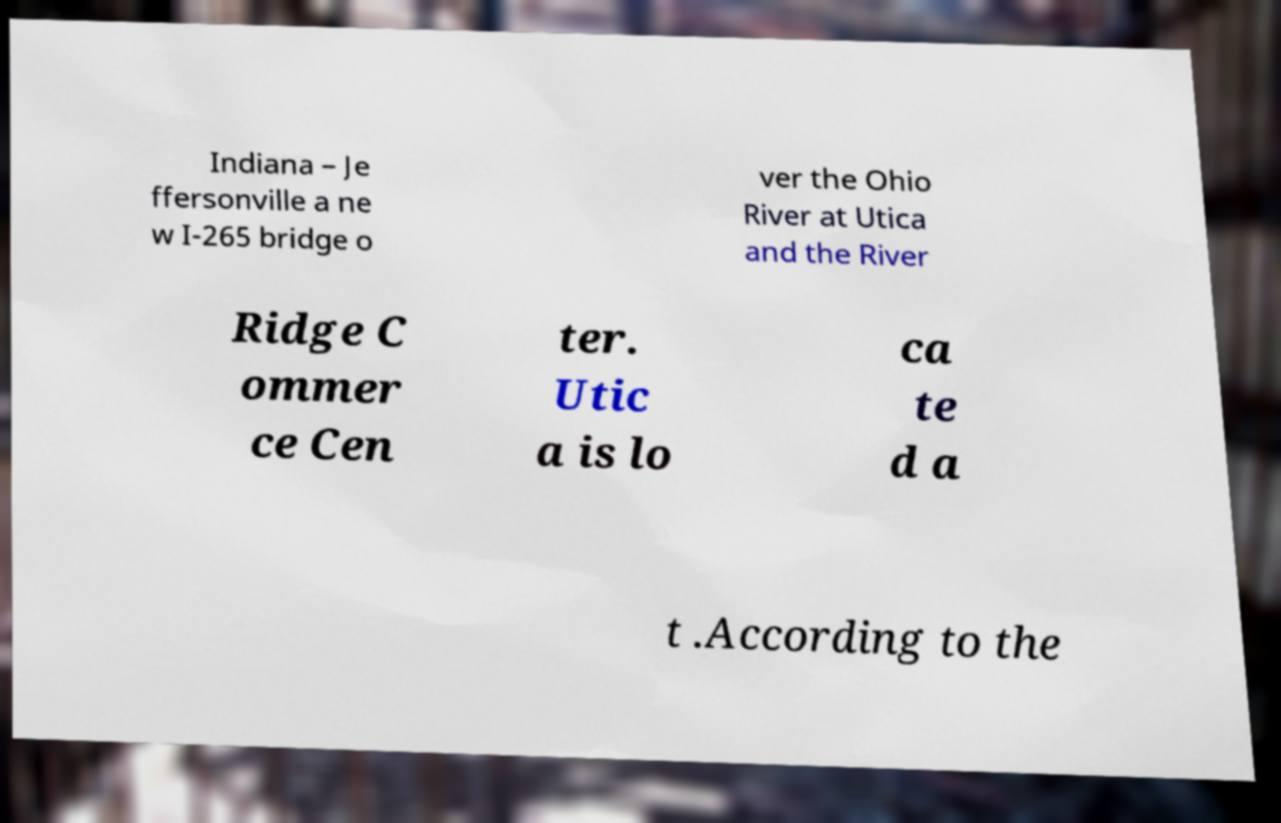Could you extract and type out the text from this image? Indiana – Je ffersonville a ne w I-265 bridge o ver the Ohio River at Utica and the River Ridge C ommer ce Cen ter. Utic a is lo ca te d a t .According to the 